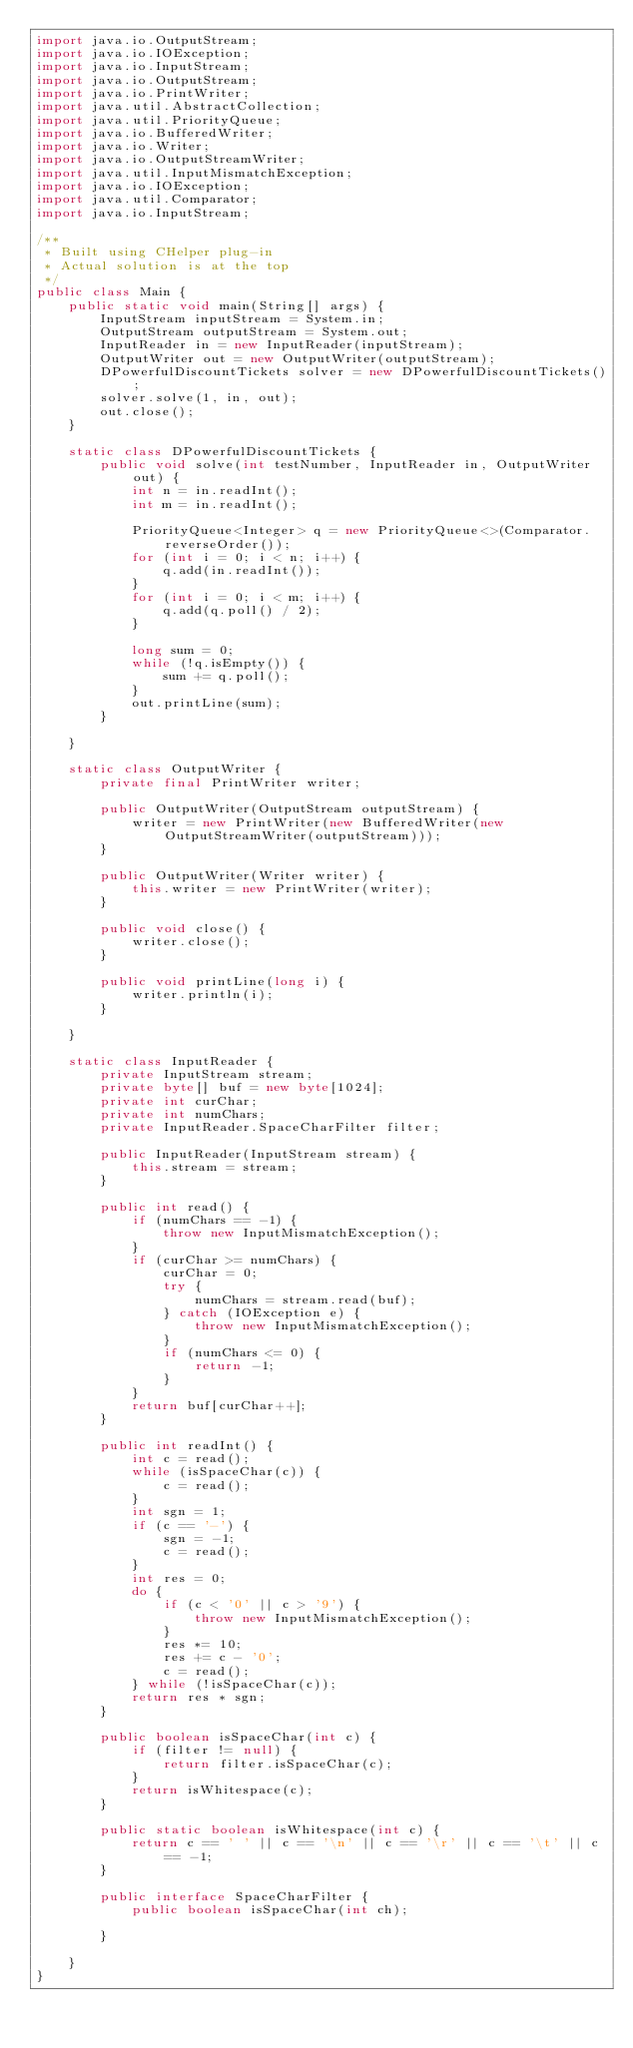<code> <loc_0><loc_0><loc_500><loc_500><_Java_>import java.io.OutputStream;
import java.io.IOException;
import java.io.InputStream;
import java.io.OutputStream;
import java.io.PrintWriter;
import java.util.AbstractCollection;
import java.util.PriorityQueue;
import java.io.BufferedWriter;
import java.io.Writer;
import java.io.OutputStreamWriter;
import java.util.InputMismatchException;
import java.io.IOException;
import java.util.Comparator;
import java.io.InputStream;

/**
 * Built using CHelper plug-in
 * Actual solution is at the top
 */
public class Main {
    public static void main(String[] args) {
        InputStream inputStream = System.in;
        OutputStream outputStream = System.out;
        InputReader in = new InputReader(inputStream);
        OutputWriter out = new OutputWriter(outputStream);
        DPowerfulDiscountTickets solver = new DPowerfulDiscountTickets();
        solver.solve(1, in, out);
        out.close();
    }

    static class DPowerfulDiscountTickets {
        public void solve(int testNumber, InputReader in, OutputWriter out) {
            int n = in.readInt();
            int m = in.readInt();

            PriorityQueue<Integer> q = new PriorityQueue<>(Comparator.reverseOrder());
            for (int i = 0; i < n; i++) {
                q.add(in.readInt());
            }
            for (int i = 0; i < m; i++) {
                q.add(q.poll() / 2);
            }

            long sum = 0;
            while (!q.isEmpty()) {
                sum += q.poll();
            }
            out.printLine(sum);
        }

    }

    static class OutputWriter {
        private final PrintWriter writer;

        public OutputWriter(OutputStream outputStream) {
            writer = new PrintWriter(new BufferedWriter(new OutputStreamWriter(outputStream)));
        }

        public OutputWriter(Writer writer) {
            this.writer = new PrintWriter(writer);
        }

        public void close() {
            writer.close();
        }

        public void printLine(long i) {
            writer.println(i);
        }

    }

    static class InputReader {
        private InputStream stream;
        private byte[] buf = new byte[1024];
        private int curChar;
        private int numChars;
        private InputReader.SpaceCharFilter filter;

        public InputReader(InputStream stream) {
            this.stream = stream;
        }

        public int read() {
            if (numChars == -1) {
                throw new InputMismatchException();
            }
            if (curChar >= numChars) {
                curChar = 0;
                try {
                    numChars = stream.read(buf);
                } catch (IOException e) {
                    throw new InputMismatchException();
                }
                if (numChars <= 0) {
                    return -1;
                }
            }
            return buf[curChar++];
        }

        public int readInt() {
            int c = read();
            while (isSpaceChar(c)) {
                c = read();
            }
            int sgn = 1;
            if (c == '-') {
                sgn = -1;
                c = read();
            }
            int res = 0;
            do {
                if (c < '0' || c > '9') {
                    throw new InputMismatchException();
                }
                res *= 10;
                res += c - '0';
                c = read();
            } while (!isSpaceChar(c));
            return res * sgn;
        }

        public boolean isSpaceChar(int c) {
            if (filter != null) {
                return filter.isSpaceChar(c);
            }
            return isWhitespace(c);
        }

        public static boolean isWhitespace(int c) {
            return c == ' ' || c == '\n' || c == '\r' || c == '\t' || c == -1;
        }

        public interface SpaceCharFilter {
            public boolean isSpaceChar(int ch);

        }

    }
}

</code> 